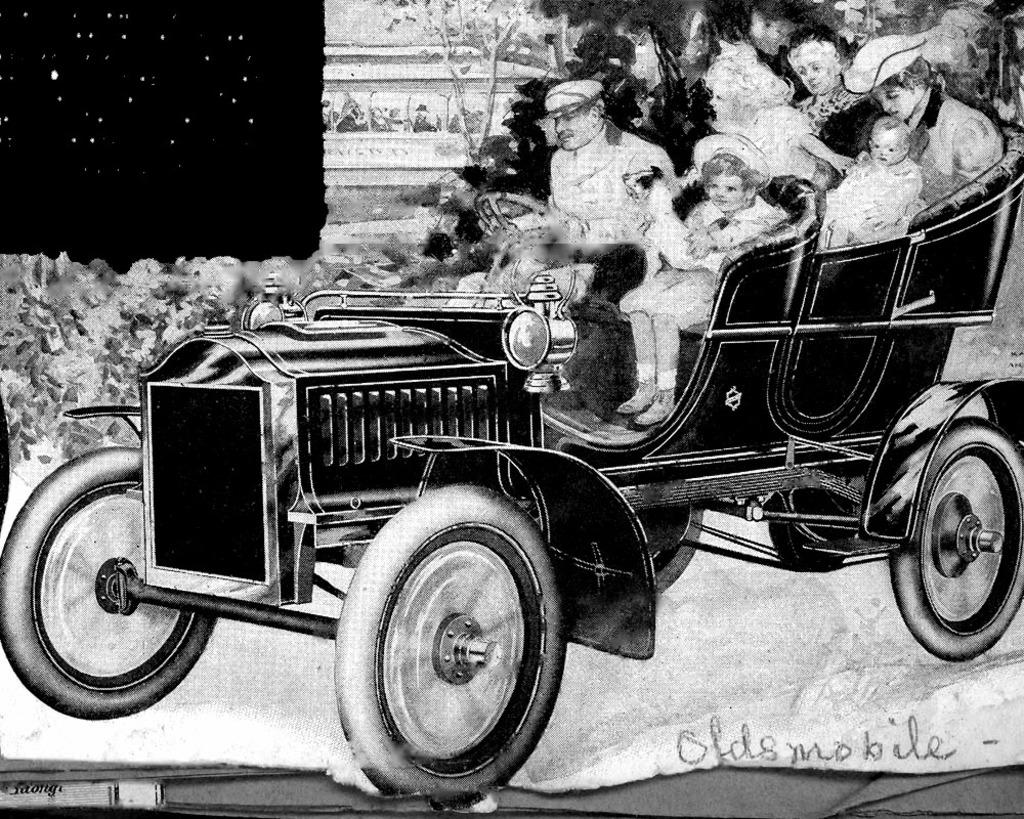What is depicted in the drawing in the image? The drawing in the image contains people sitting in a vehicle. What can be seen in the background of the image? There are trees visible in the image. Where is the text located in the image? The text is in the bottom right side of the image. How many worms can be seen crawling on the vehicle in the image? There are no worms present in the image; it features a drawing of people sitting in a vehicle with trees in the background and text in the bottom right side. 